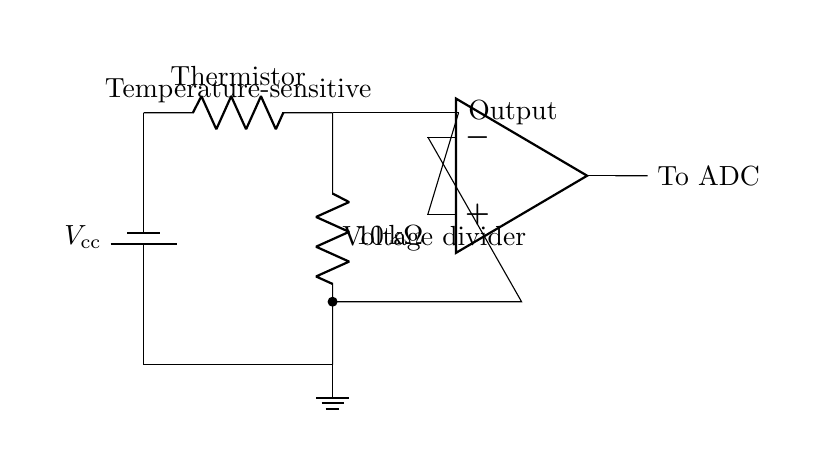What component acts as the temperature sensor? The thermistor is labeled in the circuit diagram and is indicated as the component measuring temperature changes.
Answer: Thermistor What is the resistance value of the fixed resistor? The resistor is labeled with a value of ten kilo-ohms, which is clearly stated next to the fixed resistor in the diagram.
Answer: 10 kilo-ohm What is the function of the op-amp in this circuit? The operational amplifier (op-amp) takes the output from the thermistor and amplifies the voltage signal, as implied by its position in the circuit prior to signal output to the ADC.
Answer: Amplification Which type of circuit configuration is used for the thermistor and fixed resistor? The thermistor and fixed resistor are connected in a way that indicates they form a voltage divider, allowing the measurement of the varying voltage based on temperature changes.
Answer: Voltage divider What does "To ADC" indicate in the circuit? "To ADC" signifies that the output of the op-amp is directed to an Analog-to-Digital Converter, where the analog signal will be converted into a digital format for processing and display.
Answer: Signal output 